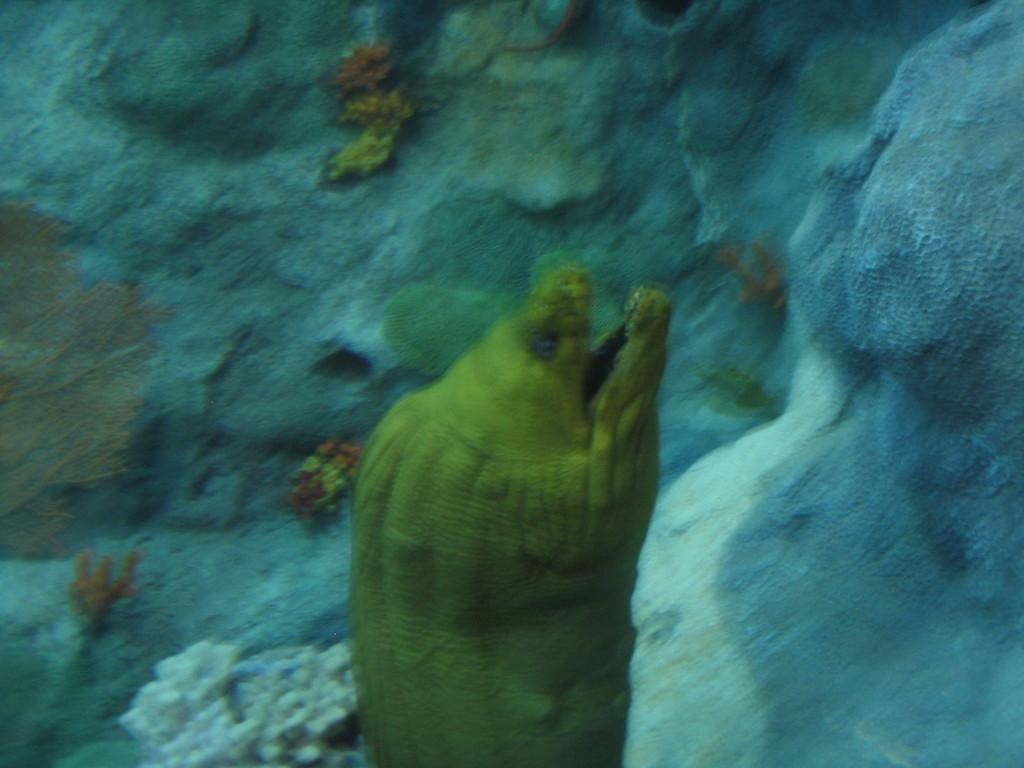What is the main subject in the foreground of the image? There is a fish in the foreground of the image. Where is the fish located? The fish is underwater. What can be seen in the background of the image? There are plants and a rock in the background of the image. How does the fish breathe in the image? The fish does not breathe in the image; it is a still image and does not show any breathing activity. 